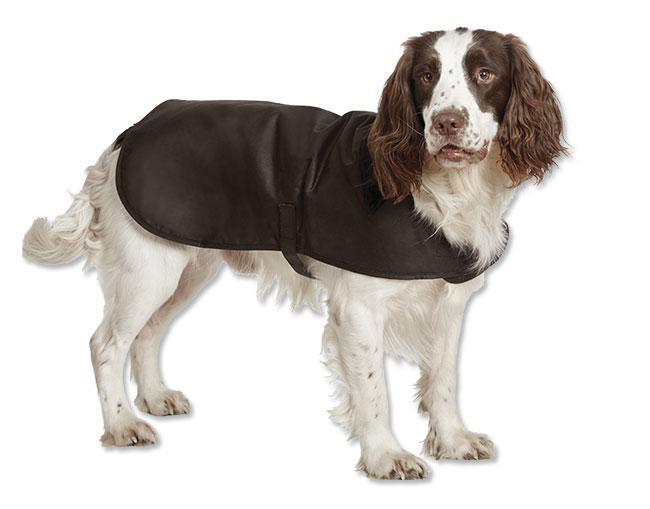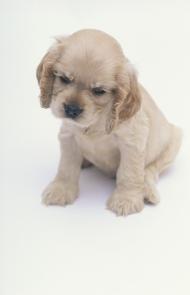The first image is the image on the left, the second image is the image on the right. Evaluate the accuracy of this statement regarding the images: "a dog is wearing a coat strapped under it's belly". Is it true? Answer yes or no. Yes. 